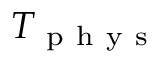<formula> <loc_0><loc_0><loc_500><loc_500>T _ { p h y s }</formula> 